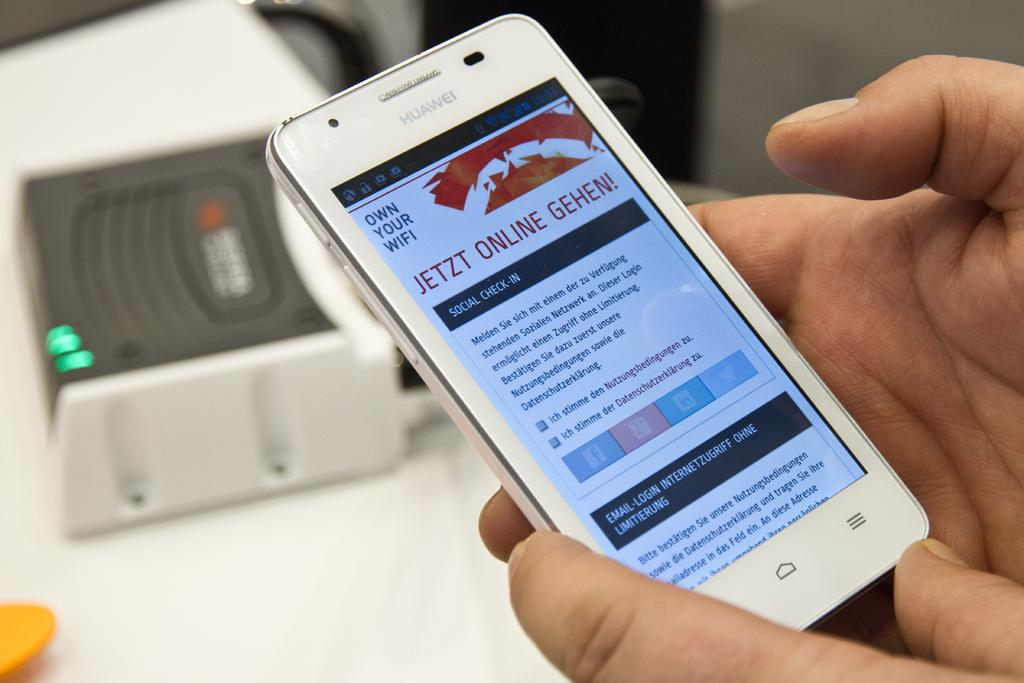<image>
Offer a succinct explanation of the picture presented. A person holding their phone that's on a page with the title Jetzt Online Gehen. 